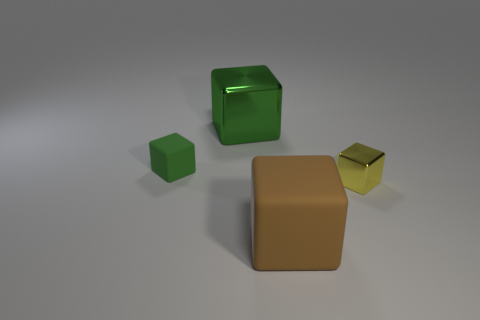What number of small metal objects are the same color as the big metallic block?
Ensure brevity in your answer.  0. The small rubber thing that is the same shape as the yellow shiny object is what color?
Provide a succinct answer. Green. There is a thing that is both right of the tiny rubber cube and behind the yellow shiny thing; what is its material?
Provide a succinct answer. Metal. Is the material of the tiny cube that is right of the brown matte thing the same as the large green thing that is to the left of the brown rubber block?
Offer a terse response. Yes. The green matte thing has what size?
Keep it short and to the point. Small. There is a brown matte object that is the same shape as the yellow object; what is its size?
Provide a short and direct response. Large. How many matte objects are behind the tiny green matte object?
Provide a short and direct response. 0. There is a metallic cube behind the yellow metallic block that is right of the large green block; what color is it?
Provide a short and direct response. Green. Are there any other things that are the same shape as the green metal object?
Ensure brevity in your answer.  Yes. Is the number of green rubber objects in front of the brown cube the same as the number of large metal cubes on the right side of the large metal cube?
Keep it short and to the point. Yes. 